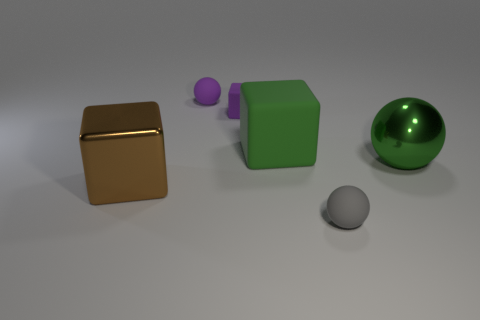Can you describe the different objects and their materials shown in the image? Certainly! There are four objects: a shiny golden cube that looks like metal, a matte purple sphere and a smaller gray sphere likely made of plastic or resin, and a green cube that could be made of a matte plastic or possibly painted wood. 